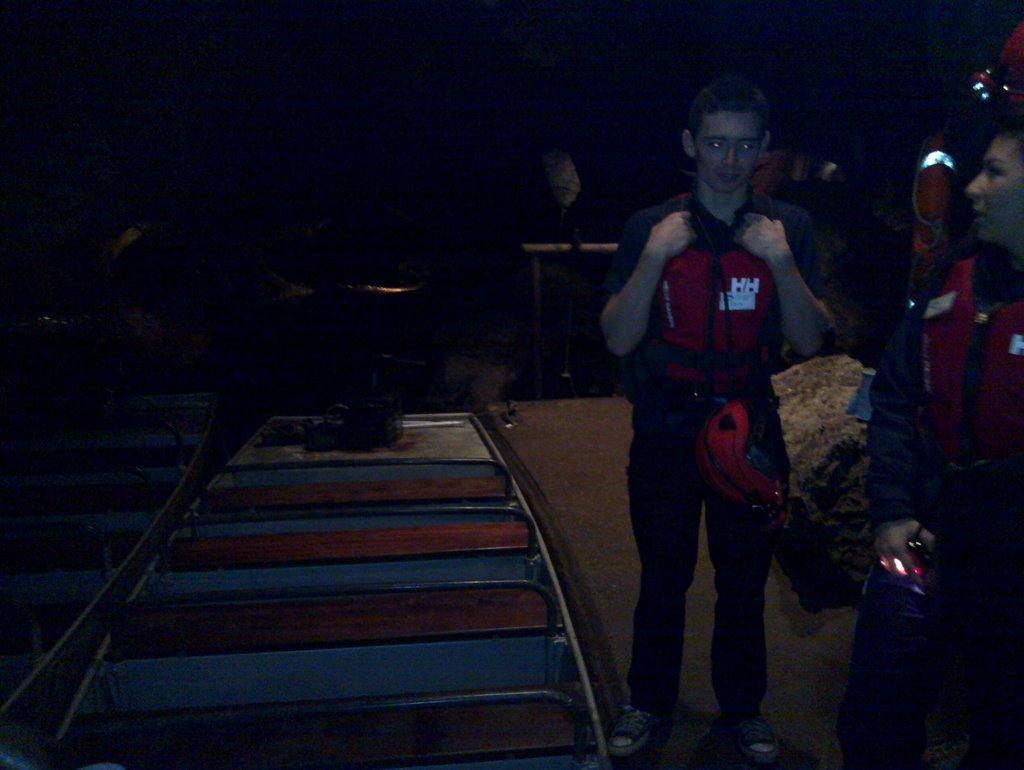What is happening in the image? There are people standing in the image. What can be seen in the background of the image? There are tracks visible in the background of the image. What type of humor can be seen in the shape of the man's hat in the image? There is no man or hat present in the image, so it is not possible to determine the type of humor in the shape of a hat. 